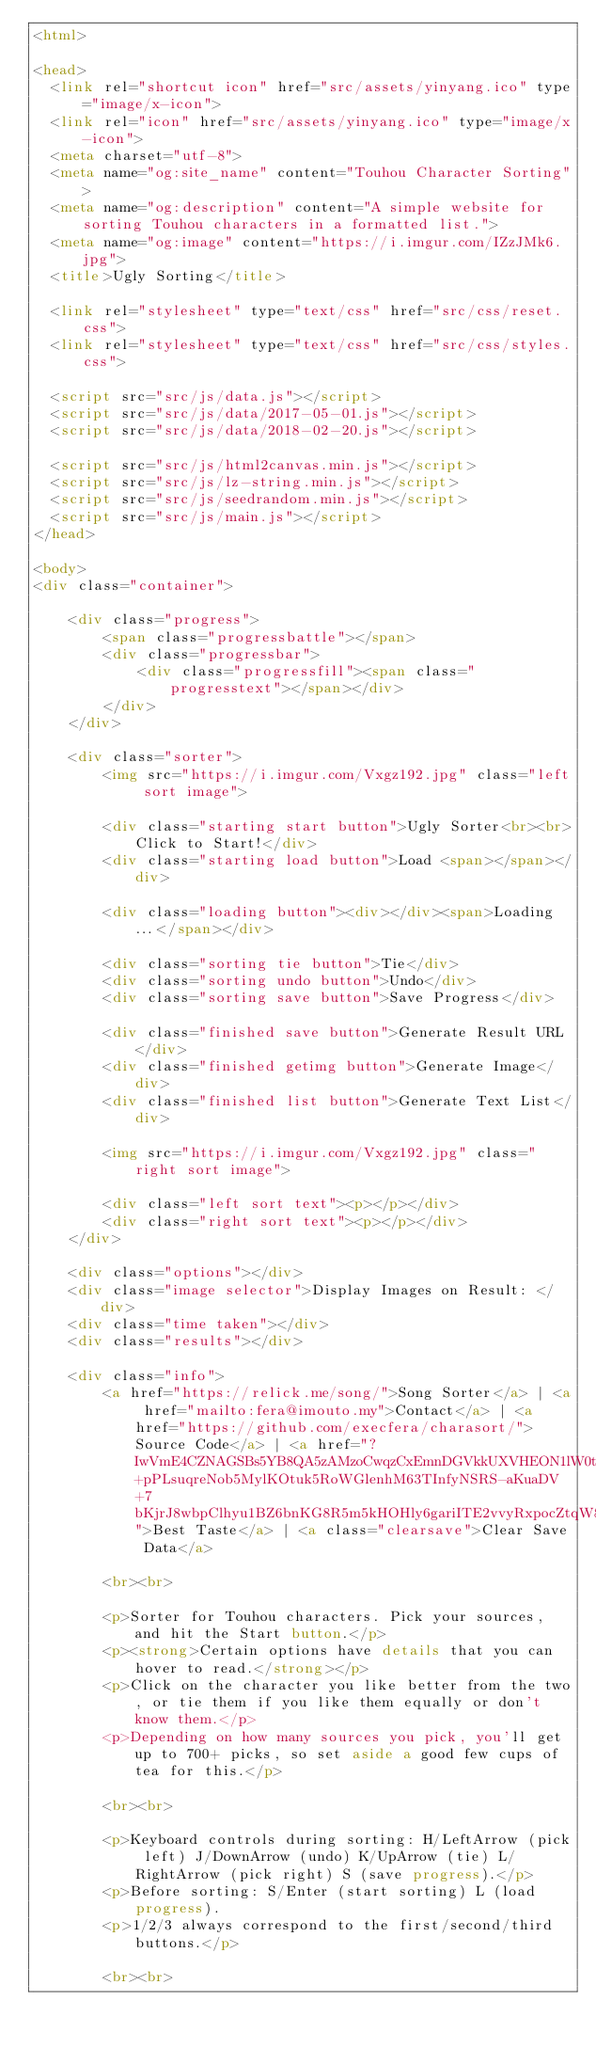Convert code to text. <code><loc_0><loc_0><loc_500><loc_500><_HTML_><html>

<head>
  <link rel="shortcut icon" href="src/assets/yinyang.ico" type="image/x-icon">
  <link rel="icon" href="src/assets/yinyang.ico" type="image/x-icon">
  <meta charset="utf-8">
  <meta name="og:site_name" content="Touhou Character Sorting">
  <meta name="og:description" content="A simple website for sorting Touhou characters in a formatted list.">
  <meta name="og:image" content="https://i.imgur.com/IZzJMk6.jpg">
  <title>Ugly Sorting</title>

  <link rel="stylesheet" type="text/css" href="src/css/reset.css">
  <link rel="stylesheet" type="text/css" href="src/css/styles.css">

  <script src="src/js/data.js"></script>
  <script src="src/js/data/2017-05-01.js"></script>
  <script src="src/js/data/2018-02-20.js"></script>

  <script src="src/js/html2canvas.min.js"></script>
  <script src="src/js/lz-string.min.js"></script>
  <script src="src/js/seedrandom.min.js"></script>
  <script src="src/js/main.js"></script>
</head>

<body>
<div class="container">

    <div class="progress">
        <span class="progressbattle"></span>
        <div class="progressbar">
            <div class="progressfill"><span class="progresstext"></span></div>
        </div>
    </div>

    <div class="sorter">
        <img src="https://i.imgur.com/Vxgz192.jpg" class="left sort image">

        <div class="starting start button">Ugly Sorter<br><br>Click to Start!</div>
        <div class="starting load button">Load <span></span></div>

        <div class="loading button"><div></div><span>Loading...</span></div>

        <div class="sorting tie button">Tie</div>
        <div class="sorting undo button">Undo</div>
        <div class="sorting save button">Save Progress</div>

        <div class="finished save button">Generate Result URL</div>
        <div class="finished getimg button">Generate Image</div>
        <div class="finished list button">Generate Text List</div>

        <img src="https://i.imgur.com/Vxgz192.jpg" class="right sort image">

        <div class="left sort text"><p></p></div>
        <div class="right sort text"><p></p></div>
    </div>

    <div class="options"></div>
    <div class="image selector">Display Images on Result: </div>
    <div class="time taken"></div>
    <div class="results"></div>

    <div class="info">
        <a href="https://relick.me/song/">Song Sorter</a> | <a href="mailto:fera@imouto.my">Contact</a> | <a href="https://github.com/execfera/charasort/">Source Code</a> | <a href="?IwVmE4CZNAGSBs5YB8QA5zAMzoCwqzCxEmnDGVkkUXVHEON1lW0tPOn1s9suNyTGr3Y0G3QcN4SBQunNaCxC+pPLsuqreNob5MylKOtuk5RoWGlenhM63TInfyNSRS-aKuaDV+7bKjrJ8wbpClhyu1BZ6bnKG8R5m5kHOHly6gariITE2vvyRxpocZtqW8moxpZ7GGbmlmbGilZXe6j75CSGtLnbAhAxAA">Best Taste</a> | <a class="clearsave">Clear Save Data</a>
        
        <br><br>

        <p>Sorter for Touhou characters. Pick your sources, and hit the Start button.</p>
        <p><strong>Certain options have details that you can hover to read.</strong></p>
        <p>Click on the character you like better from the two, or tie them if you like them equally or don't know them.</p>
        <p>Depending on how many sources you pick, you'll get up to 700+ picks, so set aside a good few cups of tea for this.</p>

        <br><br>

        <p>Keyboard controls during sorting: H/LeftArrow (pick left) J/DownArrow (undo) K/UpArrow (tie) L/RightArrow (pick right) S (save progress).</p>
        <p>Before sorting: S/Enter (start sorting) L (load progress).
        <p>1/2/3 always correspond to the first/second/third buttons.</p>
        
        <br><br>
</code> 